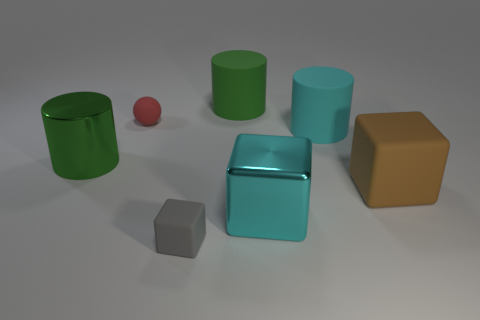Add 2 big yellow shiny things. How many objects exist? 9 Subtract all cylinders. How many objects are left? 4 Subtract all big objects. Subtract all tiny rubber cubes. How many objects are left? 1 Add 2 green cylinders. How many green cylinders are left? 4 Add 2 cylinders. How many cylinders exist? 5 Subtract 1 gray cubes. How many objects are left? 6 